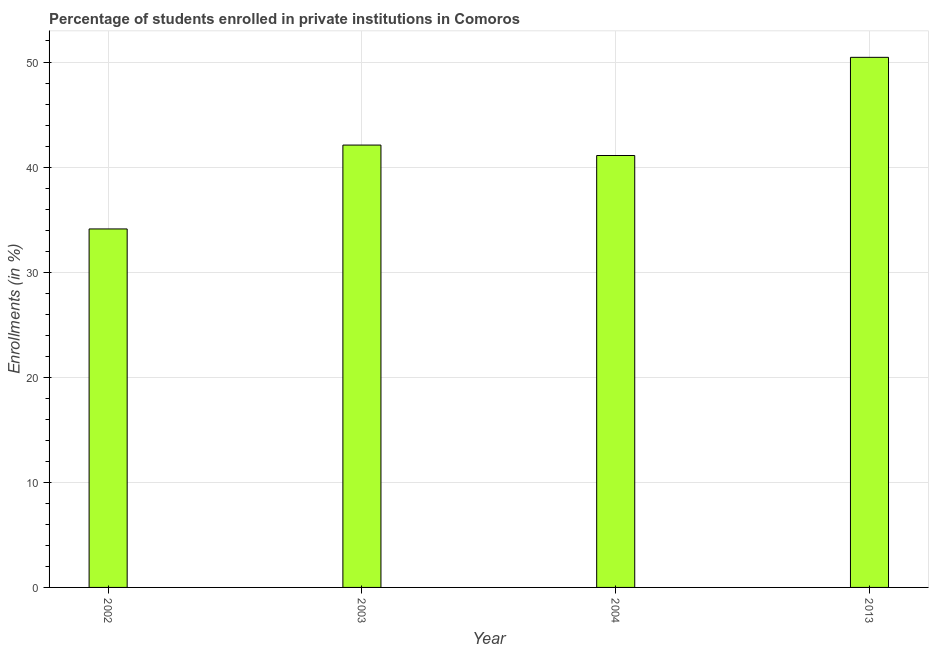Does the graph contain grids?
Your response must be concise. Yes. What is the title of the graph?
Your answer should be compact. Percentage of students enrolled in private institutions in Comoros. What is the label or title of the Y-axis?
Keep it short and to the point. Enrollments (in %). What is the enrollments in private institutions in 2002?
Offer a terse response. 34.11. Across all years, what is the maximum enrollments in private institutions?
Make the answer very short. 50.45. Across all years, what is the minimum enrollments in private institutions?
Give a very brief answer. 34.11. In which year was the enrollments in private institutions maximum?
Provide a succinct answer. 2013. What is the sum of the enrollments in private institutions?
Keep it short and to the point. 167.76. What is the difference between the enrollments in private institutions in 2002 and 2013?
Your response must be concise. -16.33. What is the average enrollments in private institutions per year?
Provide a succinct answer. 41.94. What is the median enrollments in private institutions?
Ensure brevity in your answer.  41.6. What is the ratio of the enrollments in private institutions in 2003 to that in 2004?
Offer a very short reply. 1.02. What is the difference between the highest and the second highest enrollments in private institutions?
Ensure brevity in your answer.  8.35. Is the sum of the enrollments in private institutions in 2003 and 2004 greater than the maximum enrollments in private institutions across all years?
Your response must be concise. Yes. What is the difference between the highest and the lowest enrollments in private institutions?
Give a very brief answer. 16.33. Are all the bars in the graph horizontal?
Your answer should be very brief. No. How many years are there in the graph?
Keep it short and to the point. 4. Are the values on the major ticks of Y-axis written in scientific E-notation?
Offer a very short reply. No. What is the Enrollments (in %) of 2002?
Ensure brevity in your answer.  34.11. What is the Enrollments (in %) of 2003?
Provide a short and direct response. 42.1. What is the Enrollments (in %) of 2004?
Provide a short and direct response. 41.1. What is the Enrollments (in %) in 2013?
Your response must be concise. 50.45. What is the difference between the Enrollments (in %) in 2002 and 2003?
Keep it short and to the point. -7.98. What is the difference between the Enrollments (in %) in 2002 and 2004?
Your answer should be very brief. -6.99. What is the difference between the Enrollments (in %) in 2002 and 2013?
Your answer should be very brief. -16.33. What is the difference between the Enrollments (in %) in 2003 and 2004?
Your answer should be compact. 0.99. What is the difference between the Enrollments (in %) in 2003 and 2013?
Ensure brevity in your answer.  -8.35. What is the difference between the Enrollments (in %) in 2004 and 2013?
Offer a very short reply. -9.34. What is the ratio of the Enrollments (in %) in 2002 to that in 2003?
Provide a succinct answer. 0.81. What is the ratio of the Enrollments (in %) in 2002 to that in 2004?
Provide a short and direct response. 0.83. What is the ratio of the Enrollments (in %) in 2002 to that in 2013?
Offer a terse response. 0.68. What is the ratio of the Enrollments (in %) in 2003 to that in 2013?
Ensure brevity in your answer.  0.83. What is the ratio of the Enrollments (in %) in 2004 to that in 2013?
Provide a succinct answer. 0.81. 